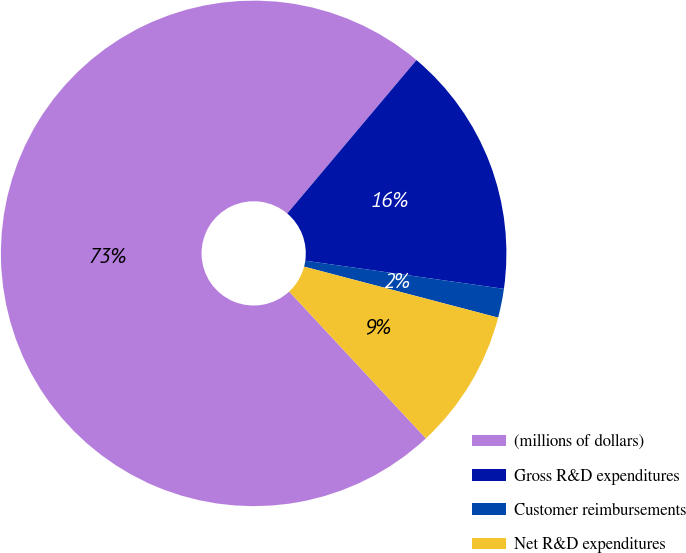Convert chart. <chart><loc_0><loc_0><loc_500><loc_500><pie_chart><fcel>(millions of dollars)<fcel>Gross R&D expenditures<fcel>Customer reimbursements<fcel>Net R&D expenditures<nl><fcel>73.07%<fcel>16.1%<fcel>1.85%<fcel>8.98%<nl></chart> 